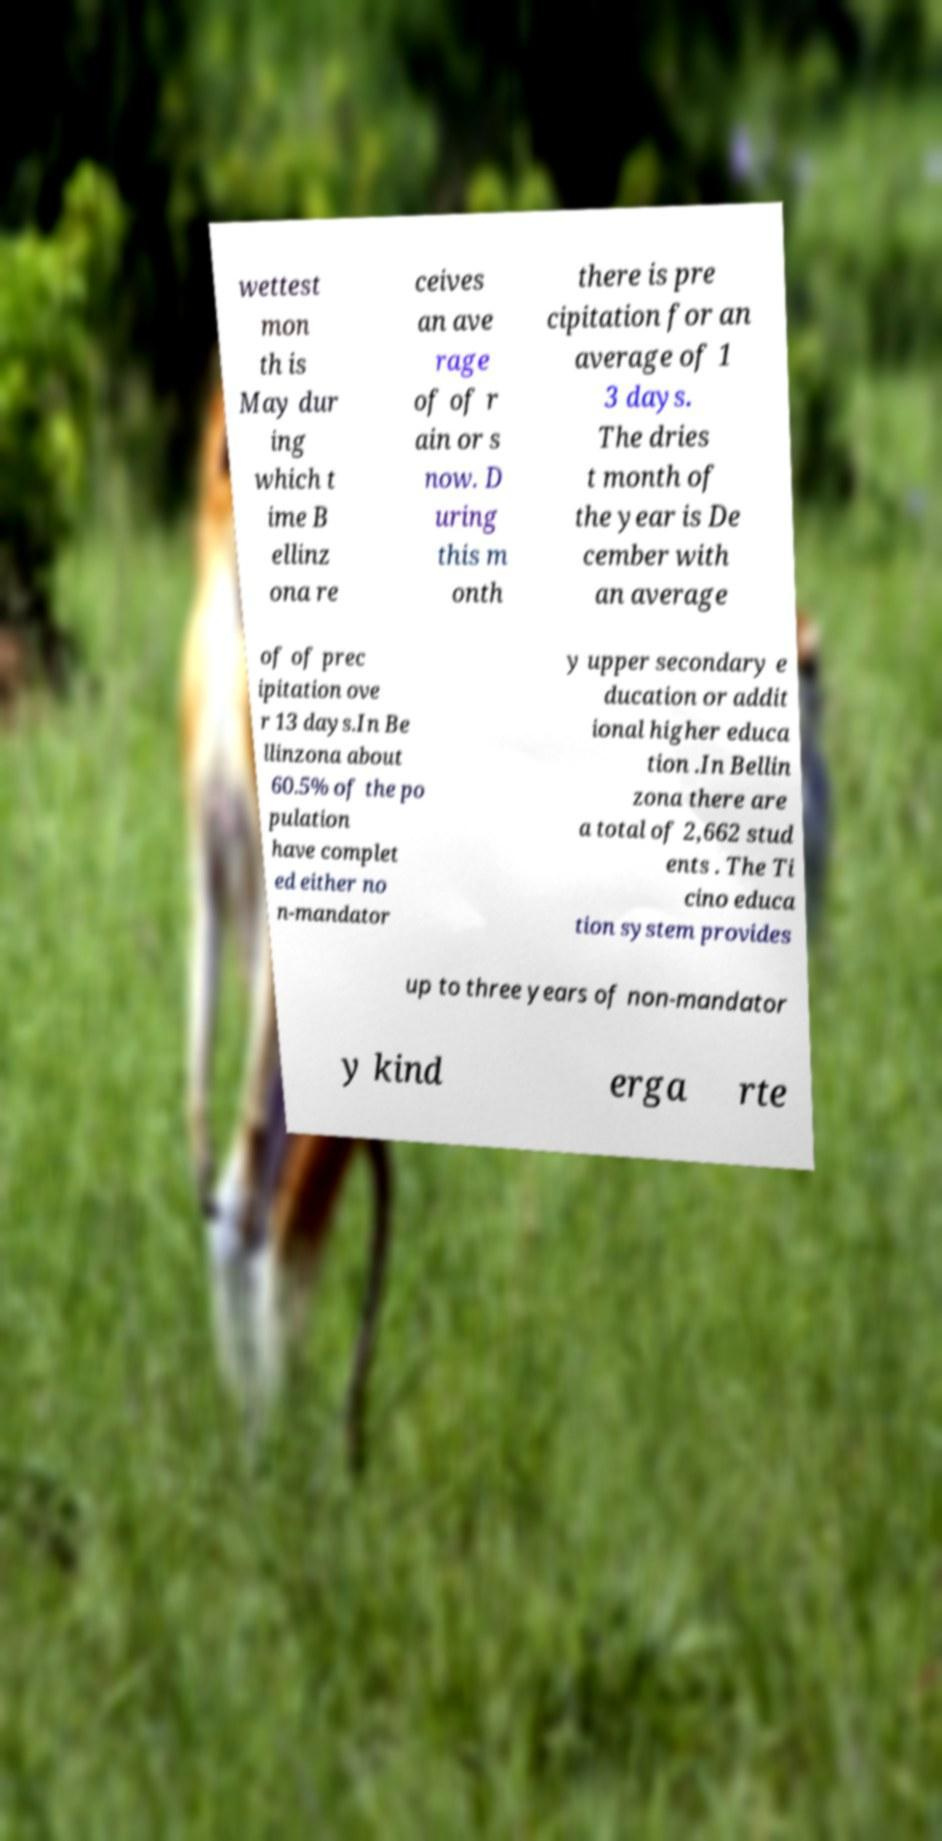Could you assist in decoding the text presented in this image and type it out clearly? wettest mon th is May dur ing which t ime B ellinz ona re ceives an ave rage of of r ain or s now. D uring this m onth there is pre cipitation for an average of 1 3 days. The dries t month of the year is De cember with an average of of prec ipitation ove r 13 days.In Be llinzona about 60.5% of the po pulation have complet ed either no n-mandator y upper secondary e ducation or addit ional higher educa tion .In Bellin zona there are a total of 2,662 stud ents . The Ti cino educa tion system provides up to three years of non-mandator y kind erga rte 